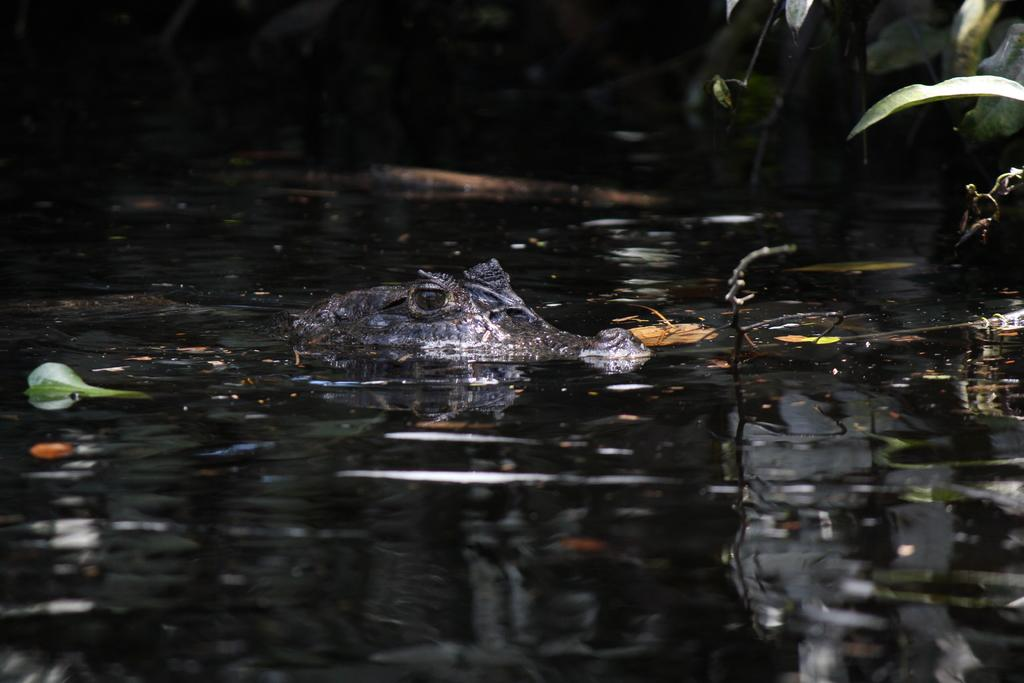What animal is in the water in the image? There is a crocodile in the water in the image. What can be seen in the background of the image? There is a group of leaves in the background of the image. What type of receipt can be seen floating on the water in the image? There is no receipt present in the image; it features a crocodile in the water and a group of leaves in the background. 